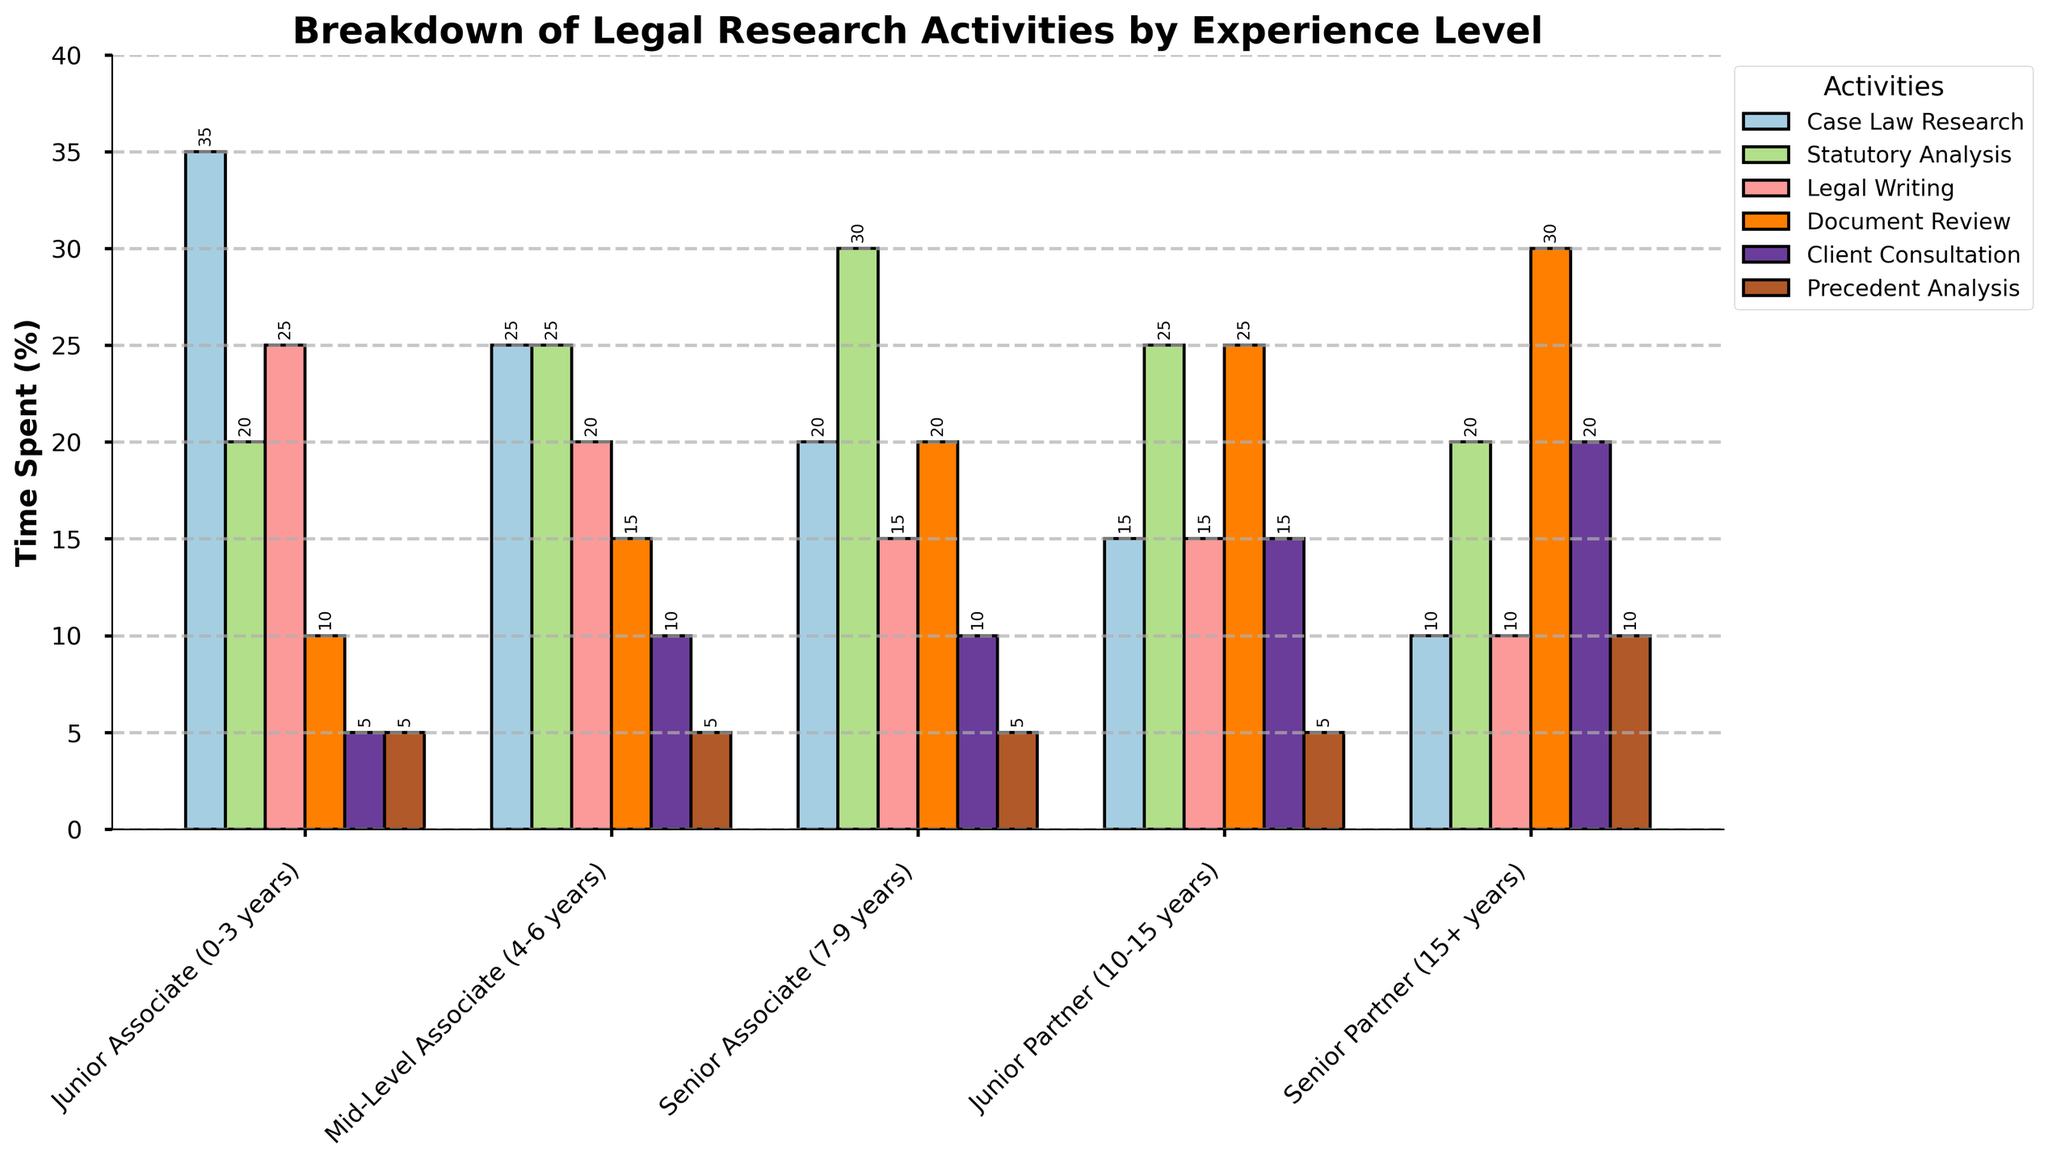What activity do attorneys spend the most time on across all experience levels? Observe the heights of the bars for each activity across all experience levels. "Case Law Research" for Junior Associates and "Document Review" for Senior Partners have the tallest bars, but overall, "Case Law Research" appears more consistently high.
Answer: Case Law Research Which activity shows an increasing trend in time spent as attorneys gain more experience? Compare the heights of the bars for each activity across increasing experience levels. "Client Consultation" shows a general increase from Junior Associate to Senior Partner.
Answer: Client Consultation What is the difference in time spent on Document Review between Junior Associates and Senior Partners? Look at the heights of the bars representing Document Review for Junior Associates and Senior Partners. Junior Associates spend 10% and Senior Partners spend 30%. The difference is 30% - 10%.
Answer: 20% Which level spends the least amount of time on Precedent Analysis? Identify the shortest bar for Precedent Analysis across all experience levels. All levels spend the same 5% on Precedent Analysis, except Senior Partners who spend 10%. The lowest is 5%.
Answer: Junior Associate, Mid-Level Associate, Senior Associate, Junior Partner Calculate the average time spent on Legal Writing across all experience levels. Add the percentages for Legal Writing for all experience levels (25 + 20 + 15 + 15 + 10) and divide by the number of levels (5). The sum is 85, so the average is 85/5.
Answer: 17% What is the sum of time spent on Statutory Analysis and Client Consultation for Junior Partners? Add the percentages of time spent on Statutory Analysis (25%) and Client Consultation (15%) for Junior Partners.
Answer: 40% Which activity has the most time spent by Senior Partners, and how much is it? Identify the tallest bar for Senior Partners and read its percentage. The tallest bar is for Document Review at 30%.
Answer: Document Review, 30% Compare the time spent on Precedent Analysis by Senior Associates and Senior Partners. Check the heights of the bars for Precedent Analysis for Senior Associates and Senior Partners. Both levels spend 5%, so they are equal.
Answer: Equal Which experience level spends the most time on Legal Writing, and what percentage is it? Find the tallest bar for Legal Writing across the different experience levels. Junior Associates spend the most time at 25%.
Answer: Junior Associate, 25% What is the combined time spent on Case Law Research and Document Review by Mid-Level Associates? Add the percentages of time spent on Case Law Research (25%) and Document Review (15%) by Mid-Level Associates.
Answer: 40% 